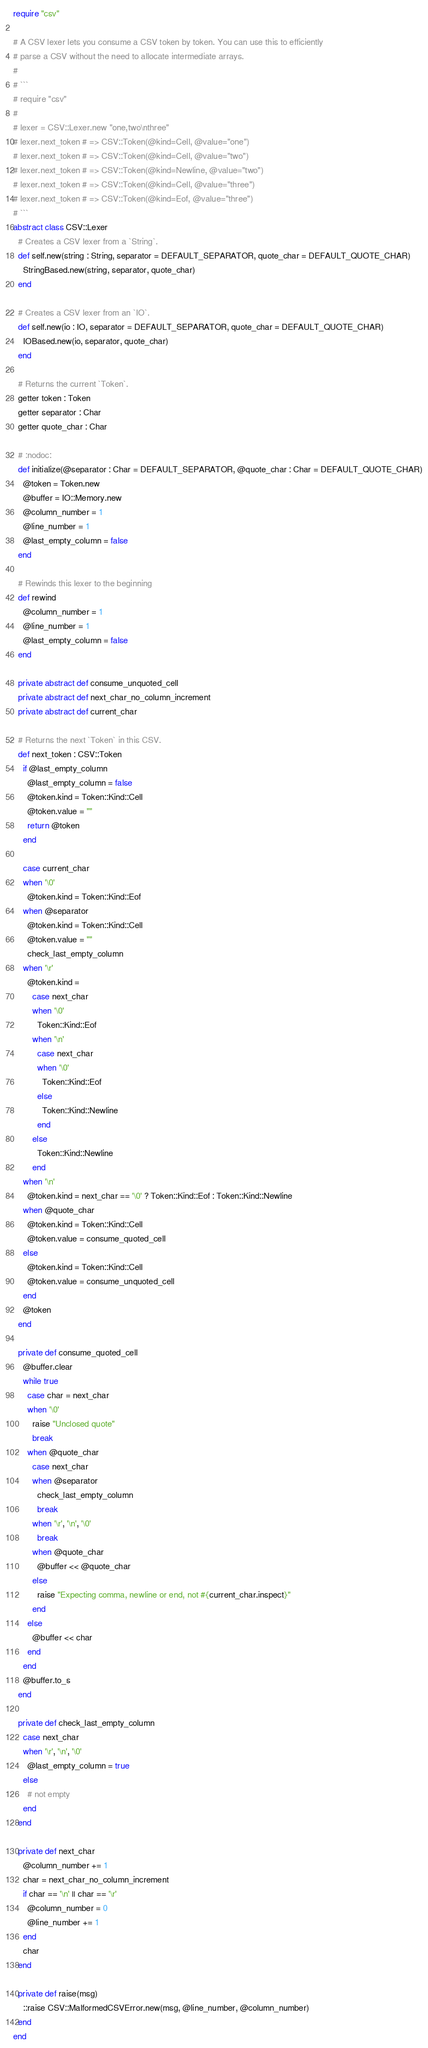<code> <loc_0><loc_0><loc_500><loc_500><_Crystal_>require "csv"

# A CSV lexer lets you consume a CSV token by token. You can use this to efficiently
# parse a CSV without the need to allocate intermediate arrays.
#
# ```
# require "csv"
#
# lexer = CSV::Lexer.new "one,two\nthree"
# lexer.next_token # => CSV::Token(@kind=Cell, @value="one")
# lexer.next_token # => CSV::Token(@kind=Cell, @value="two")
# lexer.next_token # => CSV::Token(@kind=Newline, @value="two")
# lexer.next_token # => CSV::Token(@kind=Cell, @value="three")
# lexer.next_token # => CSV::Token(@kind=Eof, @value="three")
# ```
abstract class CSV::Lexer
  # Creates a CSV lexer from a `String`.
  def self.new(string : String, separator = DEFAULT_SEPARATOR, quote_char = DEFAULT_QUOTE_CHAR)
    StringBased.new(string, separator, quote_char)
  end

  # Creates a CSV lexer from an `IO`.
  def self.new(io : IO, separator = DEFAULT_SEPARATOR, quote_char = DEFAULT_QUOTE_CHAR)
    IOBased.new(io, separator, quote_char)
  end

  # Returns the current `Token`.
  getter token : Token
  getter separator : Char
  getter quote_char : Char

  # :nodoc:
  def initialize(@separator : Char = DEFAULT_SEPARATOR, @quote_char : Char = DEFAULT_QUOTE_CHAR)
    @token = Token.new
    @buffer = IO::Memory.new
    @column_number = 1
    @line_number = 1
    @last_empty_column = false
  end

  # Rewinds this lexer to the beginning
  def rewind
    @column_number = 1
    @line_number = 1
    @last_empty_column = false
  end

  private abstract def consume_unquoted_cell
  private abstract def next_char_no_column_increment
  private abstract def current_char

  # Returns the next `Token` in this CSV.
  def next_token : CSV::Token
    if @last_empty_column
      @last_empty_column = false
      @token.kind = Token::Kind::Cell
      @token.value = ""
      return @token
    end

    case current_char
    when '\0'
      @token.kind = Token::Kind::Eof
    when @separator
      @token.kind = Token::Kind::Cell
      @token.value = ""
      check_last_empty_column
    when '\r'
      @token.kind =
        case next_char
        when '\0'
          Token::Kind::Eof
        when '\n'
          case next_char
          when '\0'
            Token::Kind::Eof
          else
            Token::Kind::Newline
          end
        else
          Token::Kind::Newline
        end
    when '\n'
      @token.kind = next_char == '\0' ? Token::Kind::Eof : Token::Kind::Newline
    when @quote_char
      @token.kind = Token::Kind::Cell
      @token.value = consume_quoted_cell
    else
      @token.kind = Token::Kind::Cell
      @token.value = consume_unquoted_cell
    end
    @token
  end

  private def consume_quoted_cell
    @buffer.clear
    while true
      case char = next_char
      when '\0'
        raise "Unclosed quote"
        break
      when @quote_char
        case next_char
        when @separator
          check_last_empty_column
          break
        when '\r', '\n', '\0'
          break
        when @quote_char
          @buffer << @quote_char
        else
          raise "Expecting comma, newline or end, not #{current_char.inspect}"
        end
      else
        @buffer << char
      end
    end
    @buffer.to_s
  end

  private def check_last_empty_column
    case next_char
    when '\r', '\n', '\0'
      @last_empty_column = true
    else
      # not empty
    end
  end

  private def next_char
    @column_number += 1
    char = next_char_no_column_increment
    if char == '\n' || char == '\r'
      @column_number = 0
      @line_number += 1
    end
    char
  end

  private def raise(msg)
    ::raise CSV::MalformedCSVError.new(msg, @line_number, @column_number)
  end
end
</code> 